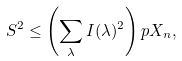Convert formula to latex. <formula><loc_0><loc_0><loc_500><loc_500>S ^ { 2 } \leq \left ( \sum _ { \lambda } I ( \lambda ) ^ { 2 } \right ) p X _ { n } ,</formula> 